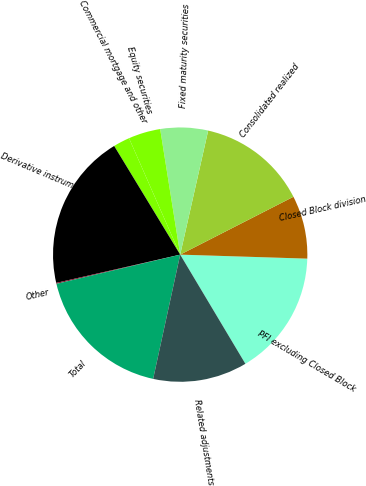<chart> <loc_0><loc_0><loc_500><loc_500><pie_chart><fcel>PFI excluding Closed Block<fcel>Closed Block division<fcel>Consolidated realized<fcel>Fixed maturity securities<fcel>Equity securities<fcel>Commercial mortgage and other<fcel>Derivative instruments<fcel>Other<fcel>Total<fcel>Related adjustments<nl><fcel>15.93%<fcel>8.02%<fcel>13.95%<fcel>6.05%<fcel>4.07%<fcel>2.1%<fcel>19.88%<fcel>0.12%<fcel>17.9%<fcel>11.98%<nl></chart> 